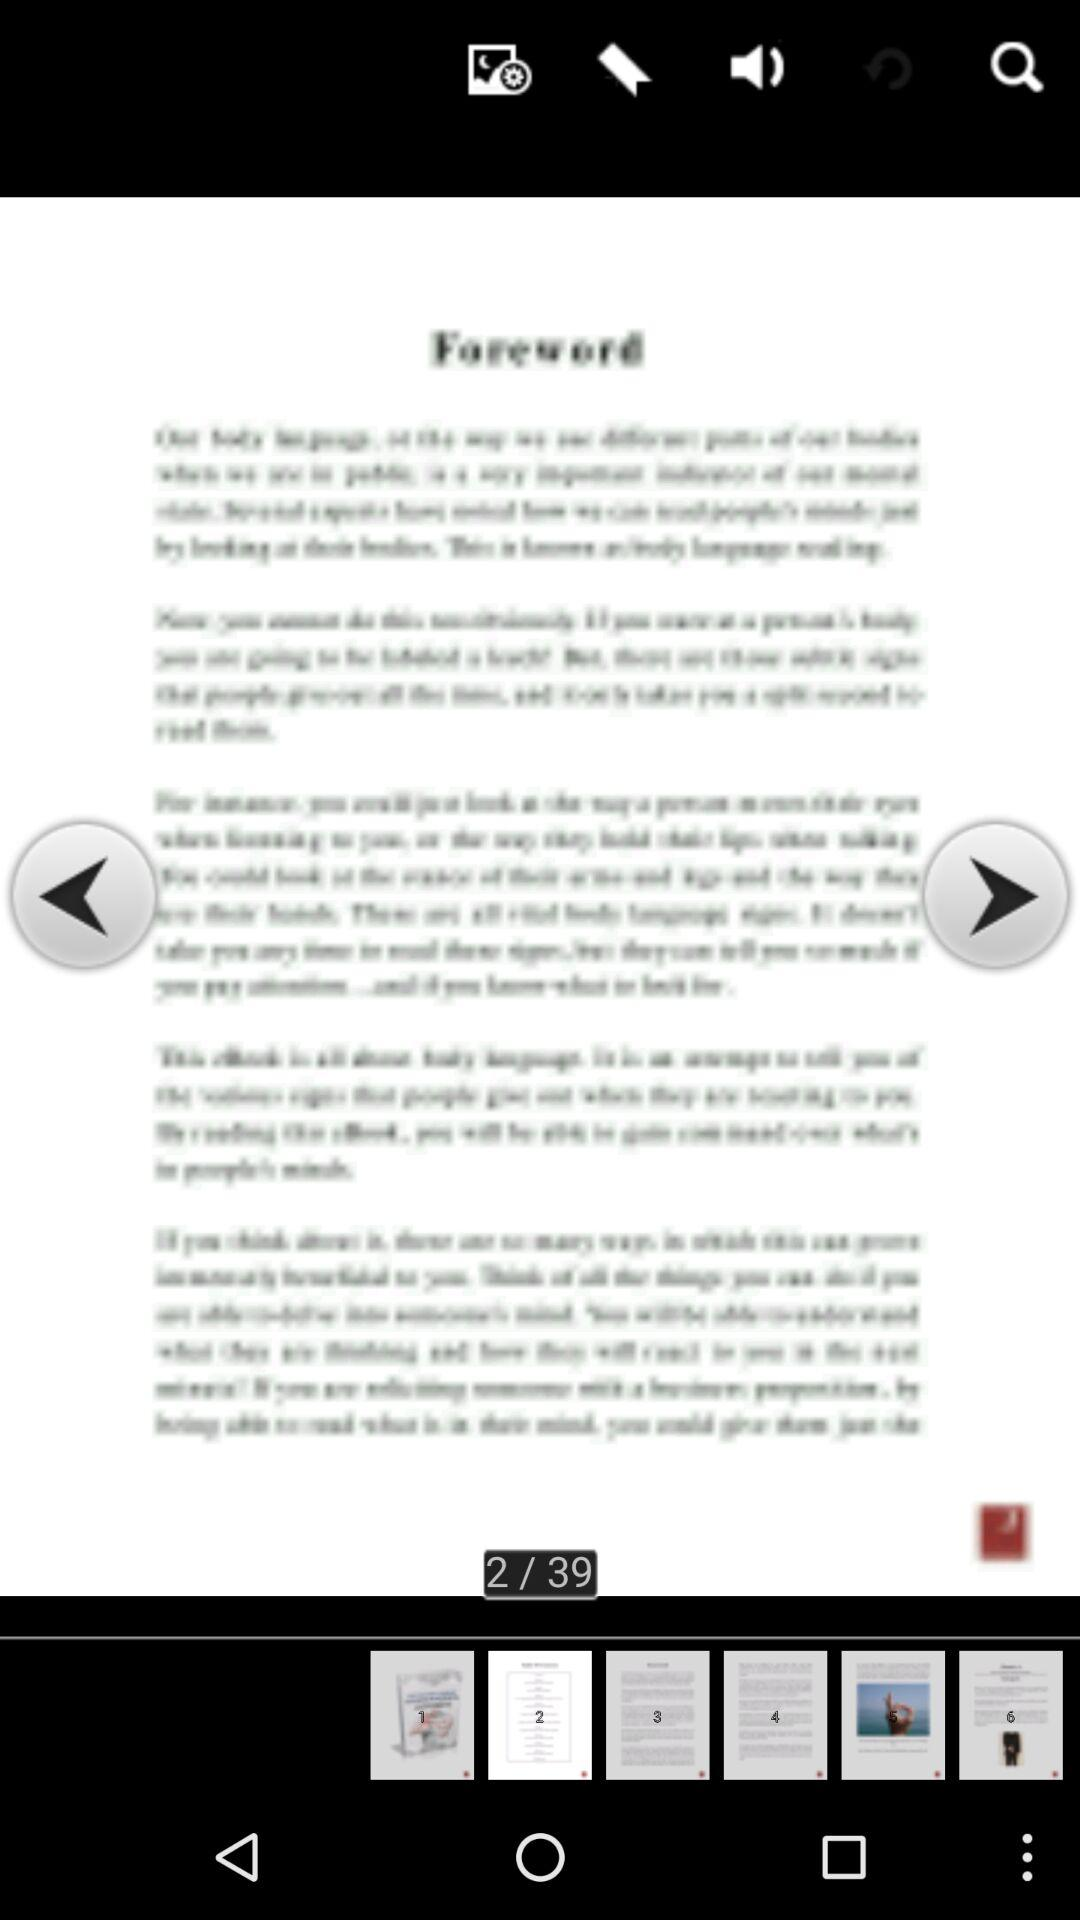Which page number are we on? You are on the second page. 